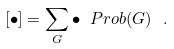Convert formula to latex. <formula><loc_0><loc_0><loc_500><loc_500>[ \bullet ] = \sum _ { G } \bullet \ P r o b ( G ) \ .</formula> 